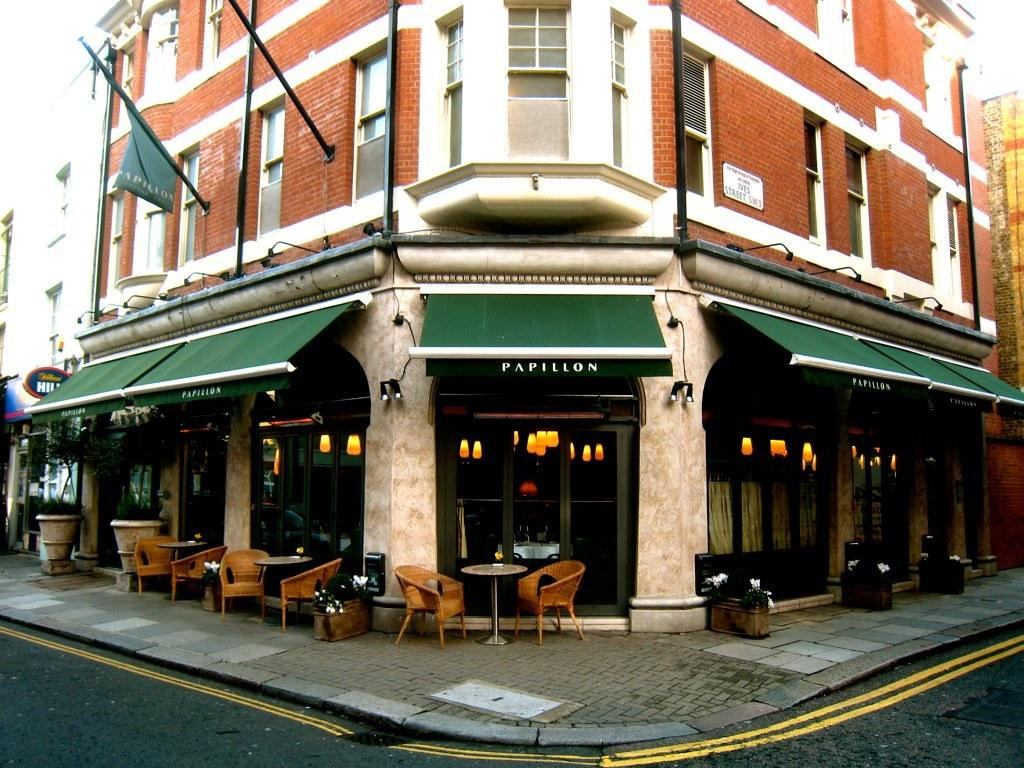What type of structure is visible in the image? There is a building in the image. What material is the building made of? The building is made up of red bricks. What furniture is placed on the footpath in front of the building? There are chairs and tables on the footpath in front of the building. What type of wool is being used to cover the yard in the image? There is no yard or wool present in the image; it features a building with chairs and tables on the tables on the footpath. 